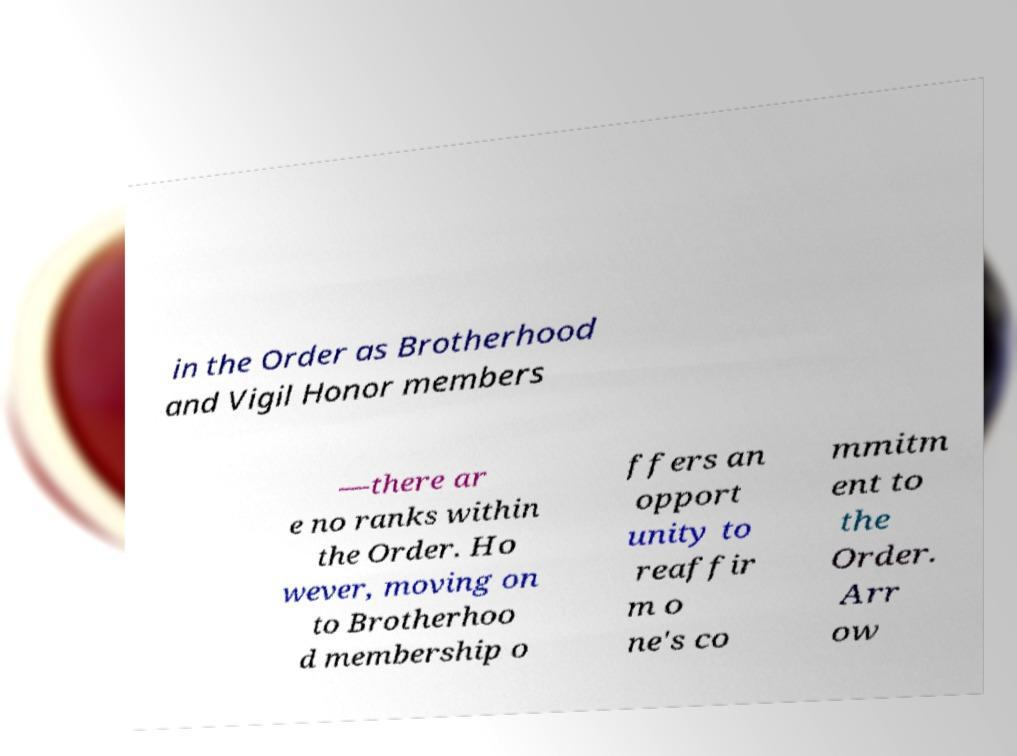For documentation purposes, I need the text within this image transcribed. Could you provide that? in the Order as Brotherhood and Vigil Honor members —there ar e no ranks within the Order. Ho wever, moving on to Brotherhoo d membership o ffers an opport unity to reaffir m o ne's co mmitm ent to the Order. Arr ow 